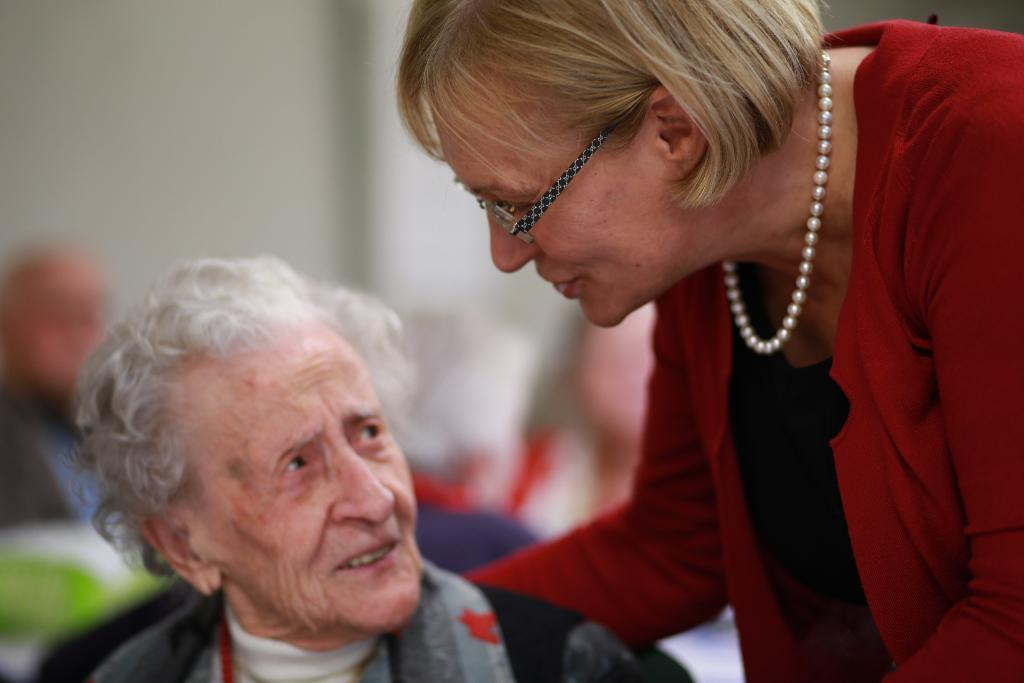How many people are present in the image? There are two persons in the image. Can you describe the background of the image? There are people and a wall in the background of the image, and the background is blurry. What type of cakes are being served to the queen in the image? There is no queen or cakes present in the image. 